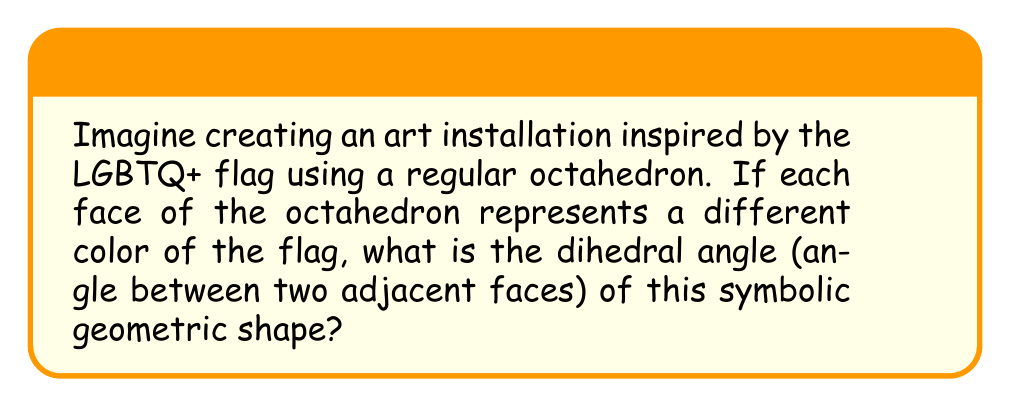Provide a solution to this math problem. Let's approach this step-by-step:

1) In a regular octahedron, all faces are congruent equilateral triangles.

2) The dihedral angle is the angle between two adjacent faces. To find this, we need to consider the angle between the normal vectors of two adjacent faces.

3) In a regular octahedron, four equilateral triangles meet at each vertex. The angle between any two face normals at a vertex is the same as the angle between two face normals of adjacent faces.

4) Consider a vertex of the octahedron. The solid angle at this vertex is:

   $$\Omega = 4 \cdot (\pi - \alpha)$$

   where $\alpha$ is the dihedral angle we're looking for.

5) The solid angle of a regular tetrahedron is $4\pi - 2\pi\sqrt{3}$. An octahedron can be thought of as two tetrahedra joined at their bases, so the solid angle at a vertex of an octahedron is half of this:

   $$\Omega = 2\pi - \pi\sqrt{3}$$

6) Equating these two expressions for $\Omega$:

   $$4(\pi - \alpha) = 2\pi - \pi\sqrt{3}$$

7) Solving for $\alpha$:

   $$4\pi - 4\alpha = 2\pi - \pi\sqrt{3}$$
   $$4\alpha = 2\pi + \pi\sqrt{3}$$
   $$\alpha = \frac{\pi}{2} + \frac{\pi\sqrt{3}}{4}$$

8) Converting to degrees:

   $$\alpha = 90^\circ + 45^\circ\sqrt{3} \approx 109.47^\circ$$

This angle, approximately 109.47°, is the dihedral angle of a regular octahedron, symbolizing the unity and interconnectedness of the different colors in the LGBTQ+ flag in this artistic representation.
Answer: $\alpha = 90^\circ + 45^\circ\sqrt{3} \approx 109.47^\circ$ 